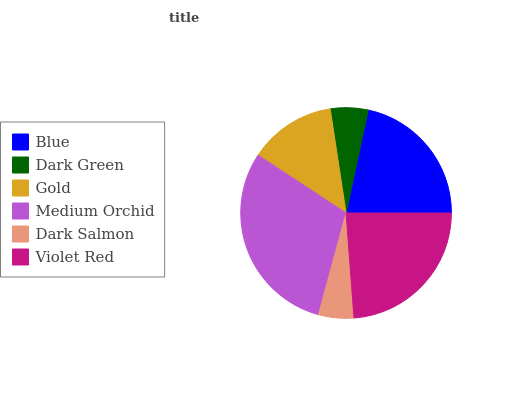Is Dark Salmon the minimum?
Answer yes or no. Yes. Is Medium Orchid the maximum?
Answer yes or no. Yes. Is Dark Green the minimum?
Answer yes or no. No. Is Dark Green the maximum?
Answer yes or no. No. Is Blue greater than Dark Green?
Answer yes or no. Yes. Is Dark Green less than Blue?
Answer yes or no. Yes. Is Dark Green greater than Blue?
Answer yes or no. No. Is Blue less than Dark Green?
Answer yes or no. No. Is Blue the high median?
Answer yes or no. Yes. Is Gold the low median?
Answer yes or no. Yes. Is Violet Red the high median?
Answer yes or no. No. Is Medium Orchid the low median?
Answer yes or no. No. 